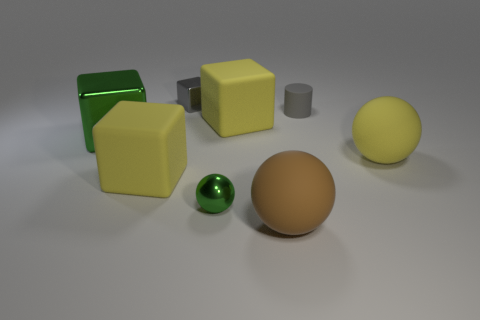Add 1 balls. How many objects exist? 9 Subtract all green blocks. How many blocks are left? 3 Subtract all balls. How many objects are left? 5 Subtract all brown spheres. Subtract all purple cylinders. How many spheres are left? 2 Subtract all blue cylinders. How many brown cubes are left? 0 Subtract all matte cylinders. Subtract all tiny gray cylinders. How many objects are left? 6 Add 6 yellow blocks. How many yellow blocks are left? 8 Add 8 small brown matte objects. How many small brown matte objects exist? 8 Subtract all green cubes. How many cubes are left? 3 Subtract 0 yellow cylinders. How many objects are left? 8 